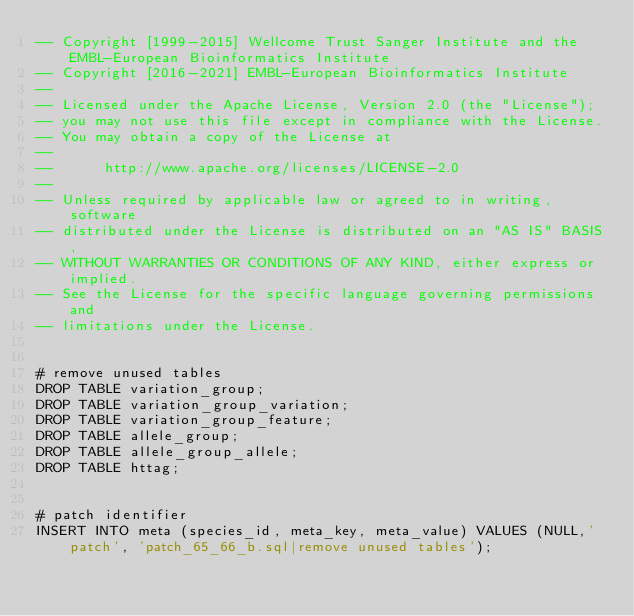<code> <loc_0><loc_0><loc_500><loc_500><_SQL_>-- Copyright [1999-2015] Wellcome Trust Sanger Institute and the EMBL-European Bioinformatics Institute
-- Copyright [2016-2021] EMBL-European Bioinformatics Institute
-- 
-- Licensed under the Apache License, Version 2.0 (the "License");
-- you may not use this file except in compliance with the License.
-- You may obtain a copy of the License at
-- 
--      http://www.apache.org/licenses/LICENSE-2.0
-- 
-- Unless required by applicable law or agreed to in writing, software
-- distributed under the License is distributed on an "AS IS" BASIS,
-- WITHOUT WARRANTIES OR CONDITIONS OF ANY KIND, either express or implied.
-- See the License for the specific language governing permissions and
-- limitations under the License.


# remove unused tables
DROP TABLE variation_group;
DROP TABLE variation_group_variation;
DROP TABLE variation_group_feature;
DROP TABLE allele_group;
DROP TABLE allele_group_allele;
DROP TABLE httag;


# patch identifier
INSERT INTO meta (species_id, meta_key, meta_value) VALUES (NULL,'patch', 'patch_65_66_b.sql|remove unused tables');

</code> 